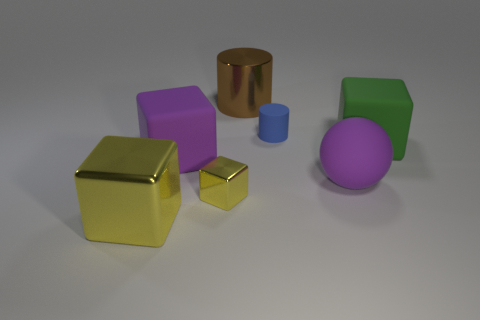What is the color of the shiny cube that is the same size as the blue matte cylinder?
Ensure brevity in your answer.  Yellow. Are there any green rubber cubes that are in front of the matte cube on the left side of the cylinder that is left of the small blue cylinder?
Your answer should be compact. No. The ball has what size?
Ensure brevity in your answer.  Large. How many objects are tiny metallic cubes or tiny cylinders?
Offer a very short reply. 2. What is the color of the big cube that is made of the same material as the tiny yellow block?
Make the answer very short. Yellow. There is a purple object that is to the right of the small shiny thing; does it have the same shape as the big green thing?
Offer a terse response. No. How many things are purple things on the left side of the tiny blue matte object or big matte blocks left of the blue rubber thing?
Offer a very short reply. 1. What color is the other matte object that is the same shape as the big green object?
Offer a terse response. Purple. Is there anything else that is the same shape as the big yellow metal thing?
Make the answer very short. Yes. There is a green matte thing; is its shape the same as the yellow thing left of the tiny shiny object?
Make the answer very short. Yes. 